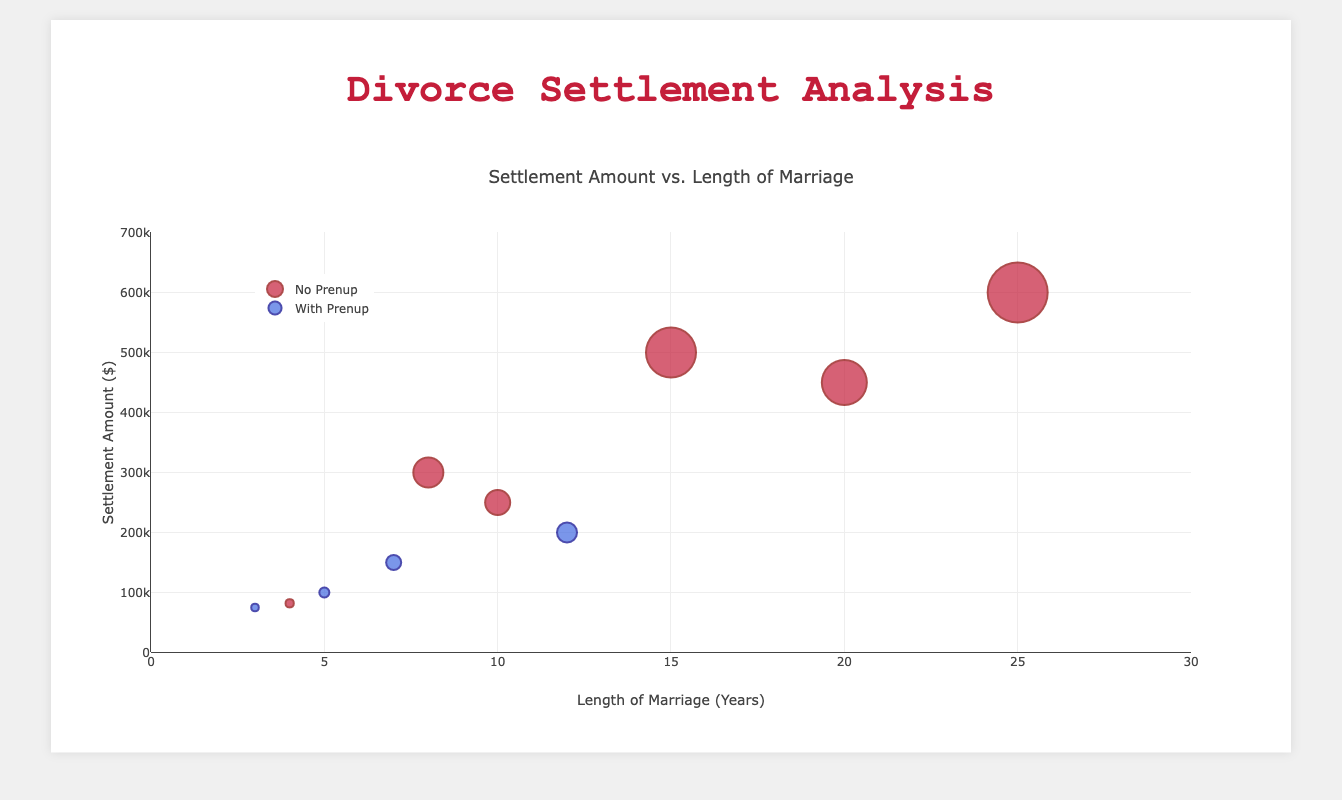How many cases have settlement amounts greater than $200,000? Look at the y-axis values and count the number of data points above $200,000. There are 2 cases with prenuptial agreements (Cases 002 and 006) and 5 without prenuptial agreements (Cases 001, 003, 005, 007, 010).
Answer: 7 Which case has the highest settlement amount? Identify the data point that is highest along the y-axis. This represents Case 010 with a settlement of $600,000.
Answer: Case 010 What is the average length of marriage for cases with prenuptial agreements? Add the lengths of marriages with prenuptial agreements and divide by the number of these cases: (5 + 3 + 12 + 7) / 4 = 27 / 4
Answer: 6.75 years Is there a general trend between the length of the marriage and settlement amounts for cases without prenuptial agreements? Observe the clustering and pattern of the data points with no prenuptial agreements (red bubbles). Generally, longer marriages appear to have a higher settlement amount.
Answer: Yes, longer marriages generally have higher settlements Are there more cases with or without prenuptial agreements? Count the number of data points for each category by looking at the legend colors and the number of bubbles in each group. There are 6 cases without prenuptial agreements and 4 with prenuptial agreements.
Answer: More cases without prenuptial agreements Which prenup status is associated with the largest bubble size, and what is the case ID? The largest bubble size is for Case 010, which is without a prenuptial agreement.
Answer: Without prenup, Case 010 What is the most common length of marriage among the cases? Look at the x-axis and find the most frequently occurring value. Lengths of 5 and 10 years appear twice, while others appear only once. Hence, both 5 and 10 years are the most common.
Answer: 5 and 10 years What is the difference in settlement amounts between the longest and the shortest marriages? The longest marriage (25 years) has a settlement amount of $600,000 (Case 010), and the shortest marriage (3 years) has a settlement amount of $75,000 (Case 004). The difference is $600,000 - $75,000.
Answer: $525,000 What is the median settlement amount for all cases? Arrange the settlement amounts in ascending order: $75,000, $82,000, $100,000, $150,000, $200,000, $250,000, $300,000, $450,000, $500,000, $600,000. The median is the average of the 5th and 6th values: ($200,000 + $250,000) / 2.
Answer: $225,000 